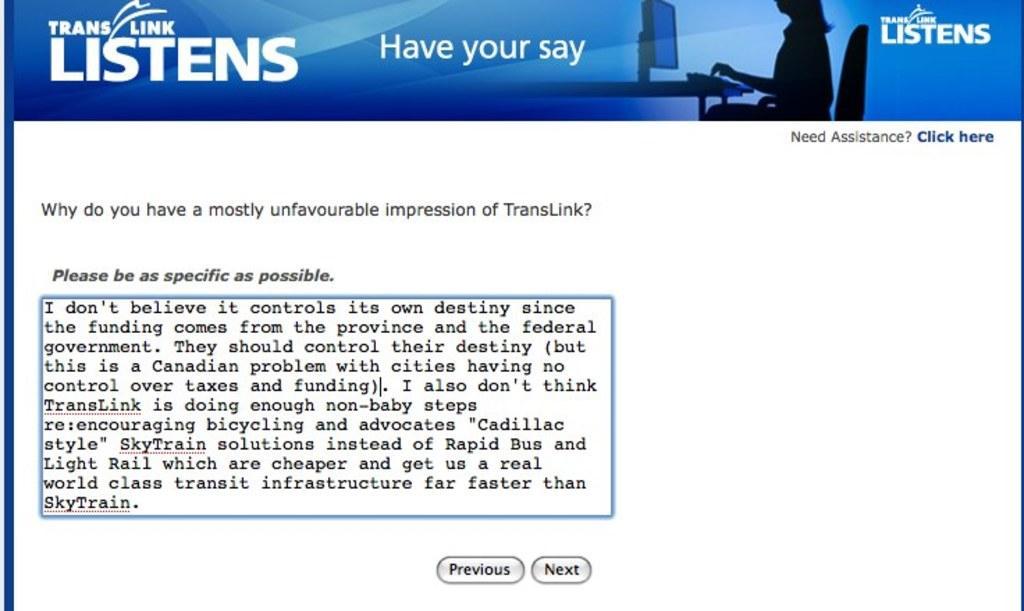How would you summarize this image in a sentence or two? In this picture, we see the monitor screen which is displaying the text. At the bottom, we see the buttons. At the top, it is blue in color and we see some text written. In the background, it is white in color. 